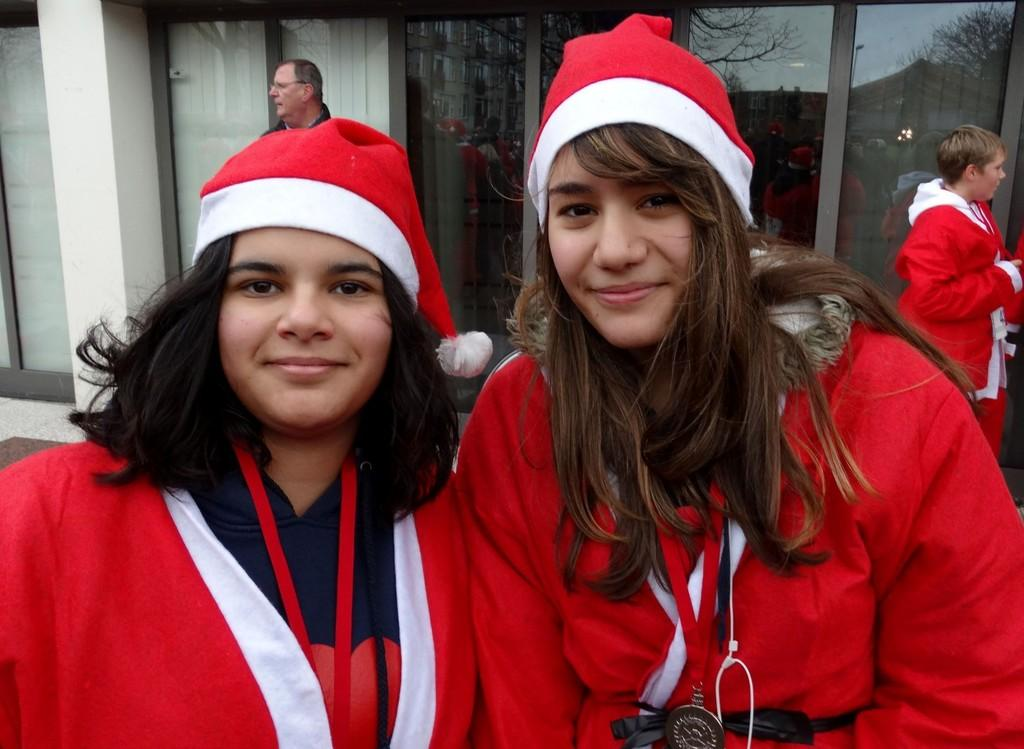How many girls are in the image? There are 2 girls in the image. What are the girls wearing? The girls are wearing Santa Claus costumes. How many other people are in the image besides the girls? There are 2 other people in the image. What type of building can be seen in the image? There is a building with glass walls in the image. What type of steel is used in the construction of the building in the image? The image does not provide information about the type of steel used in the construction of the building. 